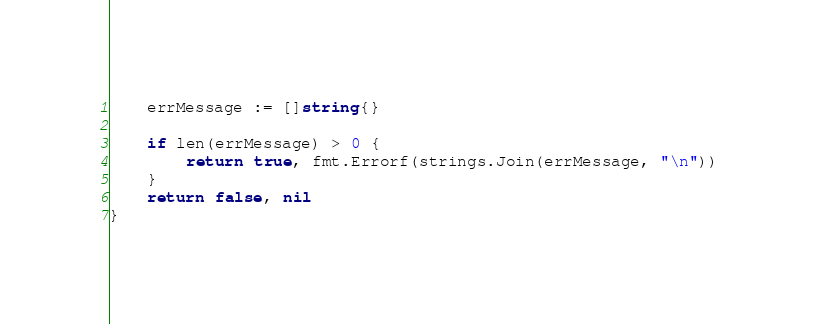Convert code to text. <code><loc_0><loc_0><loc_500><loc_500><_Go_>	errMessage := []string{}

	if len(errMessage) > 0 {
		return true, fmt.Errorf(strings.Join(errMessage, "\n"))
	}
	return false, nil
}
</code> 